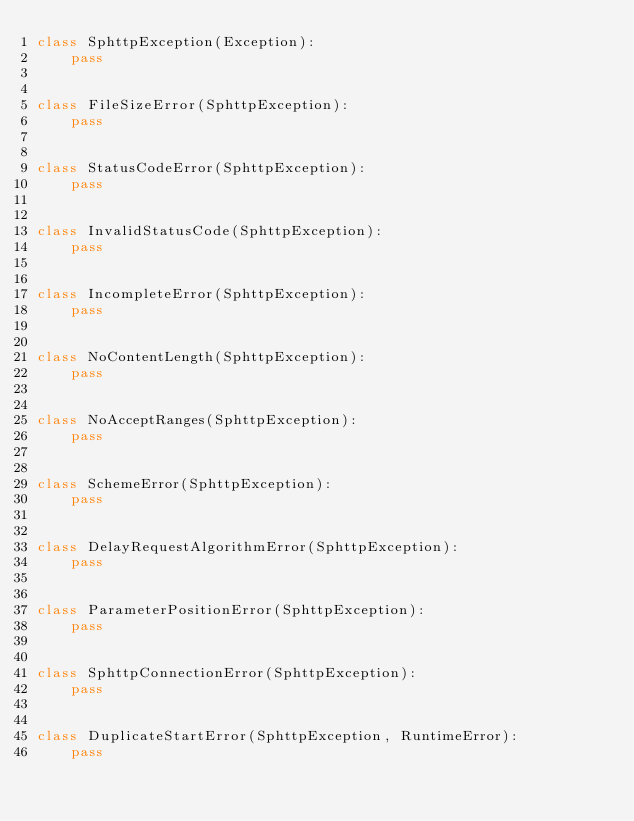<code> <loc_0><loc_0><loc_500><loc_500><_Python_>class SphttpException(Exception):
    pass


class FileSizeError(SphttpException):
    pass


class StatusCodeError(SphttpException):
    pass


class InvalidStatusCode(SphttpException):
    pass


class IncompleteError(SphttpException):
    pass


class NoContentLength(SphttpException):
    pass


class NoAcceptRanges(SphttpException):
    pass


class SchemeError(SphttpException):
    pass


class DelayRequestAlgorithmError(SphttpException):
    pass


class ParameterPositionError(SphttpException):
    pass


class SphttpConnectionError(SphttpException):
    pass


class DuplicateStartError(SphttpException, RuntimeError):
    pass
</code> 